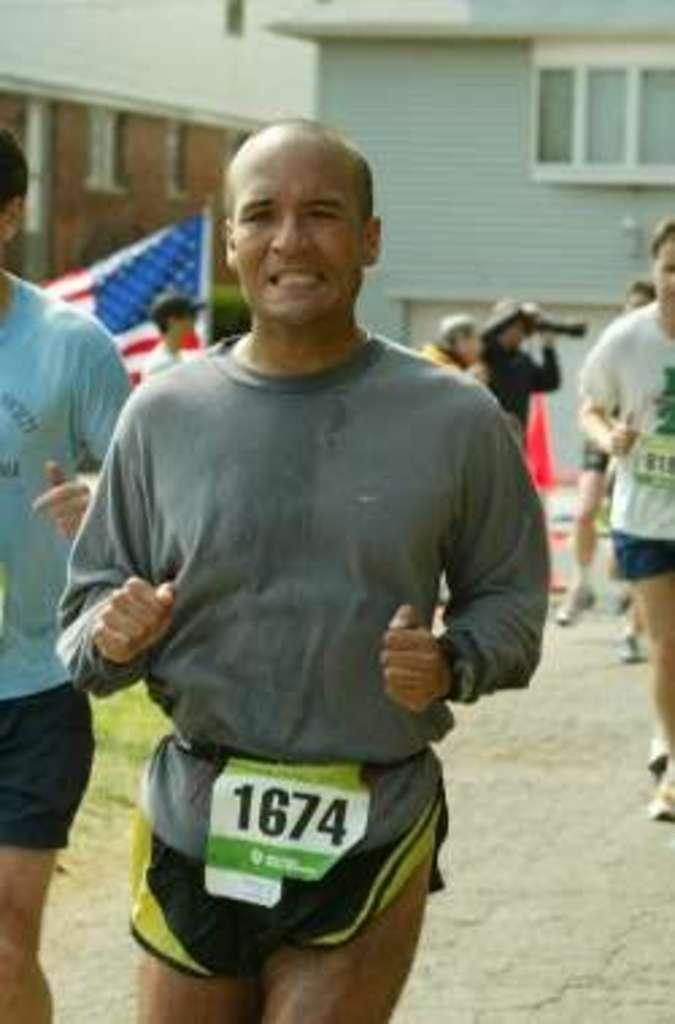Could you give a brief overview of what you see in this image? In this image there are men running, there is a road towards the bottom of the image, there are three men standing, there is a man wearing a cap, there is a man taking a photograph, there is a flag, at the background of the image there are buildings, there are windows towards the right of the image, there is a wall. 